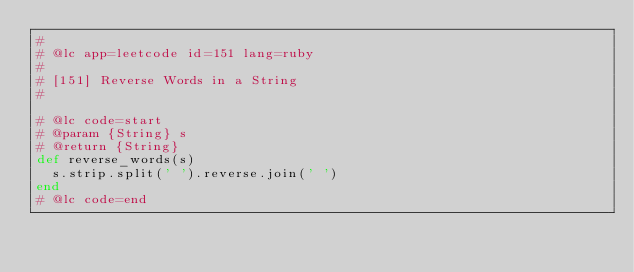<code> <loc_0><loc_0><loc_500><loc_500><_Ruby_>#
# @lc app=leetcode id=151 lang=ruby
#
# [151] Reverse Words in a String
#

# @lc code=start
# @param {String} s
# @return {String}
def reverse_words(s)
  s.strip.split(' ').reverse.join(' ')
end
# @lc code=end

</code> 